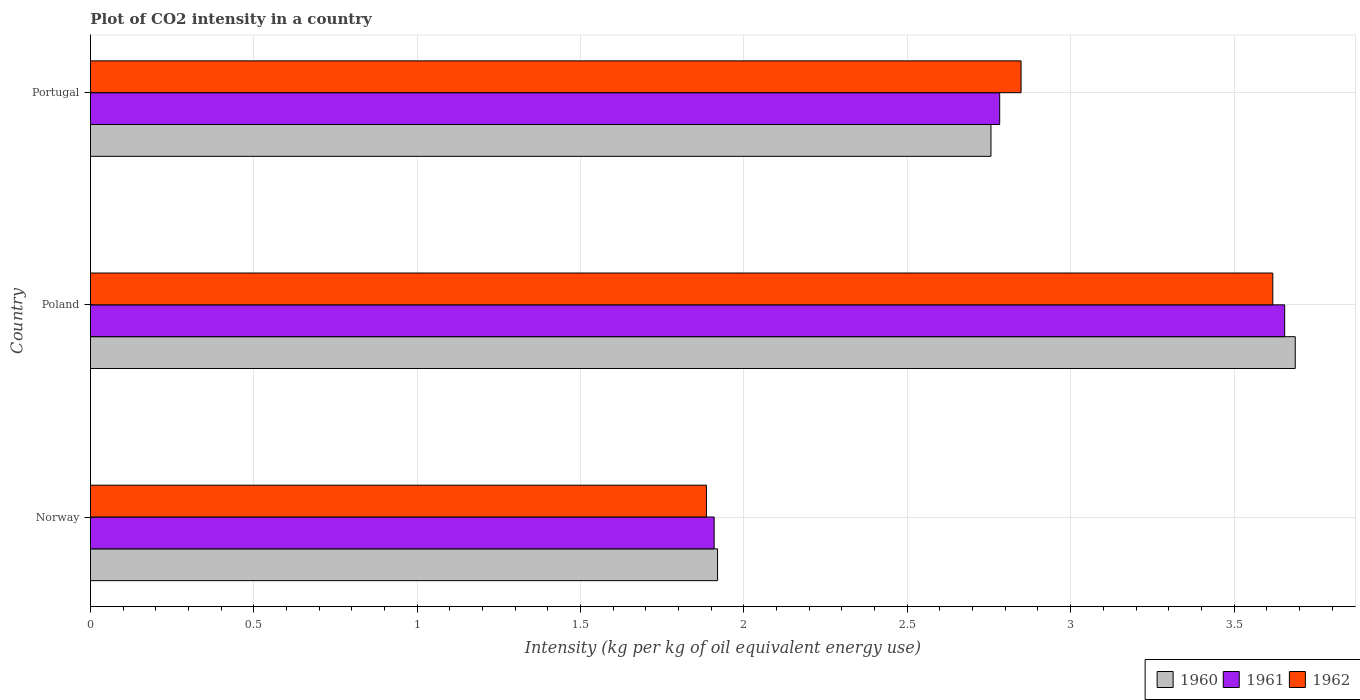How many different coloured bars are there?
Ensure brevity in your answer.  3. Are the number of bars per tick equal to the number of legend labels?
Offer a very short reply. Yes. Are the number of bars on each tick of the Y-axis equal?
Offer a very short reply. Yes. What is the label of the 3rd group of bars from the top?
Your response must be concise. Norway. What is the CO2 intensity in in 1960 in Portugal?
Your answer should be very brief. 2.76. Across all countries, what is the maximum CO2 intensity in in 1961?
Your answer should be compact. 3.66. Across all countries, what is the minimum CO2 intensity in in 1960?
Make the answer very short. 1.92. In which country was the CO2 intensity in in 1961 minimum?
Offer a terse response. Norway. What is the total CO2 intensity in in 1962 in the graph?
Your answer should be compact. 8.35. What is the difference between the CO2 intensity in in 1962 in Norway and that in Poland?
Your answer should be compact. -1.73. What is the difference between the CO2 intensity in in 1960 in Poland and the CO2 intensity in in 1962 in Norway?
Offer a very short reply. 1.8. What is the average CO2 intensity in in 1962 per country?
Ensure brevity in your answer.  2.78. What is the difference between the CO2 intensity in in 1960 and CO2 intensity in in 1962 in Poland?
Keep it short and to the point. 0.07. In how many countries, is the CO2 intensity in in 1962 greater than 2 kg?
Keep it short and to the point. 2. What is the ratio of the CO2 intensity in in 1961 in Norway to that in Poland?
Ensure brevity in your answer.  0.52. Is the CO2 intensity in in 1961 in Poland less than that in Portugal?
Your answer should be compact. No. What is the difference between the highest and the second highest CO2 intensity in in 1962?
Make the answer very short. 0.77. What is the difference between the highest and the lowest CO2 intensity in in 1961?
Give a very brief answer. 1.75. Are all the bars in the graph horizontal?
Provide a short and direct response. Yes. How many countries are there in the graph?
Offer a terse response. 3. Where does the legend appear in the graph?
Your answer should be compact. Bottom right. What is the title of the graph?
Your answer should be very brief. Plot of CO2 intensity in a country. Does "1974" appear as one of the legend labels in the graph?
Offer a terse response. No. What is the label or title of the X-axis?
Your response must be concise. Intensity (kg per kg of oil equivalent energy use). What is the label or title of the Y-axis?
Keep it short and to the point. Country. What is the Intensity (kg per kg of oil equivalent energy use) of 1960 in Norway?
Provide a succinct answer. 1.92. What is the Intensity (kg per kg of oil equivalent energy use) of 1961 in Norway?
Keep it short and to the point. 1.91. What is the Intensity (kg per kg of oil equivalent energy use) of 1962 in Norway?
Provide a succinct answer. 1.89. What is the Intensity (kg per kg of oil equivalent energy use) in 1960 in Poland?
Offer a terse response. 3.69. What is the Intensity (kg per kg of oil equivalent energy use) of 1961 in Poland?
Your answer should be very brief. 3.66. What is the Intensity (kg per kg of oil equivalent energy use) of 1962 in Poland?
Your response must be concise. 3.62. What is the Intensity (kg per kg of oil equivalent energy use) in 1960 in Portugal?
Keep it short and to the point. 2.76. What is the Intensity (kg per kg of oil equivalent energy use) in 1961 in Portugal?
Give a very brief answer. 2.78. What is the Intensity (kg per kg of oil equivalent energy use) of 1962 in Portugal?
Give a very brief answer. 2.85. Across all countries, what is the maximum Intensity (kg per kg of oil equivalent energy use) in 1960?
Make the answer very short. 3.69. Across all countries, what is the maximum Intensity (kg per kg of oil equivalent energy use) in 1961?
Give a very brief answer. 3.66. Across all countries, what is the maximum Intensity (kg per kg of oil equivalent energy use) in 1962?
Offer a very short reply. 3.62. Across all countries, what is the minimum Intensity (kg per kg of oil equivalent energy use) in 1960?
Your response must be concise. 1.92. Across all countries, what is the minimum Intensity (kg per kg of oil equivalent energy use) of 1961?
Your response must be concise. 1.91. Across all countries, what is the minimum Intensity (kg per kg of oil equivalent energy use) of 1962?
Give a very brief answer. 1.89. What is the total Intensity (kg per kg of oil equivalent energy use) in 1960 in the graph?
Provide a short and direct response. 8.36. What is the total Intensity (kg per kg of oil equivalent energy use) of 1961 in the graph?
Give a very brief answer. 8.35. What is the total Intensity (kg per kg of oil equivalent energy use) in 1962 in the graph?
Your answer should be very brief. 8.35. What is the difference between the Intensity (kg per kg of oil equivalent energy use) of 1960 in Norway and that in Poland?
Your answer should be very brief. -1.77. What is the difference between the Intensity (kg per kg of oil equivalent energy use) in 1961 in Norway and that in Poland?
Make the answer very short. -1.75. What is the difference between the Intensity (kg per kg of oil equivalent energy use) of 1962 in Norway and that in Poland?
Keep it short and to the point. -1.73. What is the difference between the Intensity (kg per kg of oil equivalent energy use) in 1960 in Norway and that in Portugal?
Your answer should be compact. -0.84. What is the difference between the Intensity (kg per kg of oil equivalent energy use) of 1961 in Norway and that in Portugal?
Ensure brevity in your answer.  -0.87. What is the difference between the Intensity (kg per kg of oil equivalent energy use) of 1962 in Norway and that in Portugal?
Provide a succinct answer. -0.96. What is the difference between the Intensity (kg per kg of oil equivalent energy use) of 1960 in Poland and that in Portugal?
Offer a very short reply. 0.93. What is the difference between the Intensity (kg per kg of oil equivalent energy use) in 1961 in Poland and that in Portugal?
Your answer should be compact. 0.87. What is the difference between the Intensity (kg per kg of oil equivalent energy use) of 1962 in Poland and that in Portugal?
Ensure brevity in your answer.  0.77. What is the difference between the Intensity (kg per kg of oil equivalent energy use) in 1960 in Norway and the Intensity (kg per kg of oil equivalent energy use) in 1961 in Poland?
Your answer should be compact. -1.74. What is the difference between the Intensity (kg per kg of oil equivalent energy use) of 1960 in Norway and the Intensity (kg per kg of oil equivalent energy use) of 1962 in Poland?
Offer a terse response. -1.7. What is the difference between the Intensity (kg per kg of oil equivalent energy use) of 1961 in Norway and the Intensity (kg per kg of oil equivalent energy use) of 1962 in Poland?
Provide a succinct answer. -1.71. What is the difference between the Intensity (kg per kg of oil equivalent energy use) of 1960 in Norway and the Intensity (kg per kg of oil equivalent energy use) of 1961 in Portugal?
Ensure brevity in your answer.  -0.86. What is the difference between the Intensity (kg per kg of oil equivalent energy use) of 1960 in Norway and the Intensity (kg per kg of oil equivalent energy use) of 1962 in Portugal?
Offer a terse response. -0.93. What is the difference between the Intensity (kg per kg of oil equivalent energy use) of 1961 in Norway and the Intensity (kg per kg of oil equivalent energy use) of 1962 in Portugal?
Provide a short and direct response. -0.94. What is the difference between the Intensity (kg per kg of oil equivalent energy use) of 1960 in Poland and the Intensity (kg per kg of oil equivalent energy use) of 1961 in Portugal?
Offer a terse response. 0.9. What is the difference between the Intensity (kg per kg of oil equivalent energy use) of 1960 in Poland and the Intensity (kg per kg of oil equivalent energy use) of 1962 in Portugal?
Provide a succinct answer. 0.84. What is the difference between the Intensity (kg per kg of oil equivalent energy use) in 1961 in Poland and the Intensity (kg per kg of oil equivalent energy use) in 1962 in Portugal?
Your answer should be compact. 0.81. What is the average Intensity (kg per kg of oil equivalent energy use) in 1960 per country?
Provide a short and direct response. 2.79. What is the average Intensity (kg per kg of oil equivalent energy use) in 1961 per country?
Ensure brevity in your answer.  2.78. What is the average Intensity (kg per kg of oil equivalent energy use) of 1962 per country?
Your answer should be compact. 2.78. What is the difference between the Intensity (kg per kg of oil equivalent energy use) in 1960 and Intensity (kg per kg of oil equivalent energy use) in 1961 in Norway?
Your response must be concise. 0.01. What is the difference between the Intensity (kg per kg of oil equivalent energy use) of 1960 and Intensity (kg per kg of oil equivalent energy use) of 1962 in Norway?
Offer a terse response. 0.03. What is the difference between the Intensity (kg per kg of oil equivalent energy use) in 1961 and Intensity (kg per kg of oil equivalent energy use) in 1962 in Norway?
Offer a terse response. 0.02. What is the difference between the Intensity (kg per kg of oil equivalent energy use) in 1960 and Intensity (kg per kg of oil equivalent energy use) in 1961 in Poland?
Your answer should be compact. 0.03. What is the difference between the Intensity (kg per kg of oil equivalent energy use) of 1960 and Intensity (kg per kg of oil equivalent energy use) of 1962 in Poland?
Give a very brief answer. 0.07. What is the difference between the Intensity (kg per kg of oil equivalent energy use) in 1961 and Intensity (kg per kg of oil equivalent energy use) in 1962 in Poland?
Give a very brief answer. 0.04. What is the difference between the Intensity (kg per kg of oil equivalent energy use) in 1960 and Intensity (kg per kg of oil equivalent energy use) in 1961 in Portugal?
Your answer should be very brief. -0.03. What is the difference between the Intensity (kg per kg of oil equivalent energy use) of 1960 and Intensity (kg per kg of oil equivalent energy use) of 1962 in Portugal?
Your answer should be compact. -0.09. What is the difference between the Intensity (kg per kg of oil equivalent energy use) of 1961 and Intensity (kg per kg of oil equivalent energy use) of 1962 in Portugal?
Your answer should be compact. -0.07. What is the ratio of the Intensity (kg per kg of oil equivalent energy use) in 1960 in Norway to that in Poland?
Provide a short and direct response. 0.52. What is the ratio of the Intensity (kg per kg of oil equivalent energy use) in 1961 in Norway to that in Poland?
Offer a very short reply. 0.52. What is the ratio of the Intensity (kg per kg of oil equivalent energy use) of 1962 in Norway to that in Poland?
Your answer should be compact. 0.52. What is the ratio of the Intensity (kg per kg of oil equivalent energy use) of 1960 in Norway to that in Portugal?
Make the answer very short. 0.7. What is the ratio of the Intensity (kg per kg of oil equivalent energy use) in 1961 in Norway to that in Portugal?
Keep it short and to the point. 0.69. What is the ratio of the Intensity (kg per kg of oil equivalent energy use) of 1962 in Norway to that in Portugal?
Offer a very short reply. 0.66. What is the ratio of the Intensity (kg per kg of oil equivalent energy use) of 1960 in Poland to that in Portugal?
Offer a terse response. 1.34. What is the ratio of the Intensity (kg per kg of oil equivalent energy use) in 1961 in Poland to that in Portugal?
Offer a terse response. 1.31. What is the ratio of the Intensity (kg per kg of oil equivalent energy use) in 1962 in Poland to that in Portugal?
Keep it short and to the point. 1.27. What is the difference between the highest and the second highest Intensity (kg per kg of oil equivalent energy use) in 1960?
Provide a succinct answer. 0.93. What is the difference between the highest and the second highest Intensity (kg per kg of oil equivalent energy use) of 1961?
Your answer should be very brief. 0.87. What is the difference between the highest and the second highest Intensity (kg per kg of oil equivalent energy use) of 1962?
Make the answer very short. 0.77. What is the difference between the highest and the lowest Intensity (kg per kg of oil equivalent energy use) in 1960?
Provide a succinct answer. 1.77. What is the difference between the highest and the lowest Intensity (kg per kg of oil equivalent energy use) of 1961?
Offer a terse response. 1.75. What is the difference between the highest and the lowest Intensity (kg per kg of oil equivalent energy use) of 1962?
Offer a terse response. 1.73. 